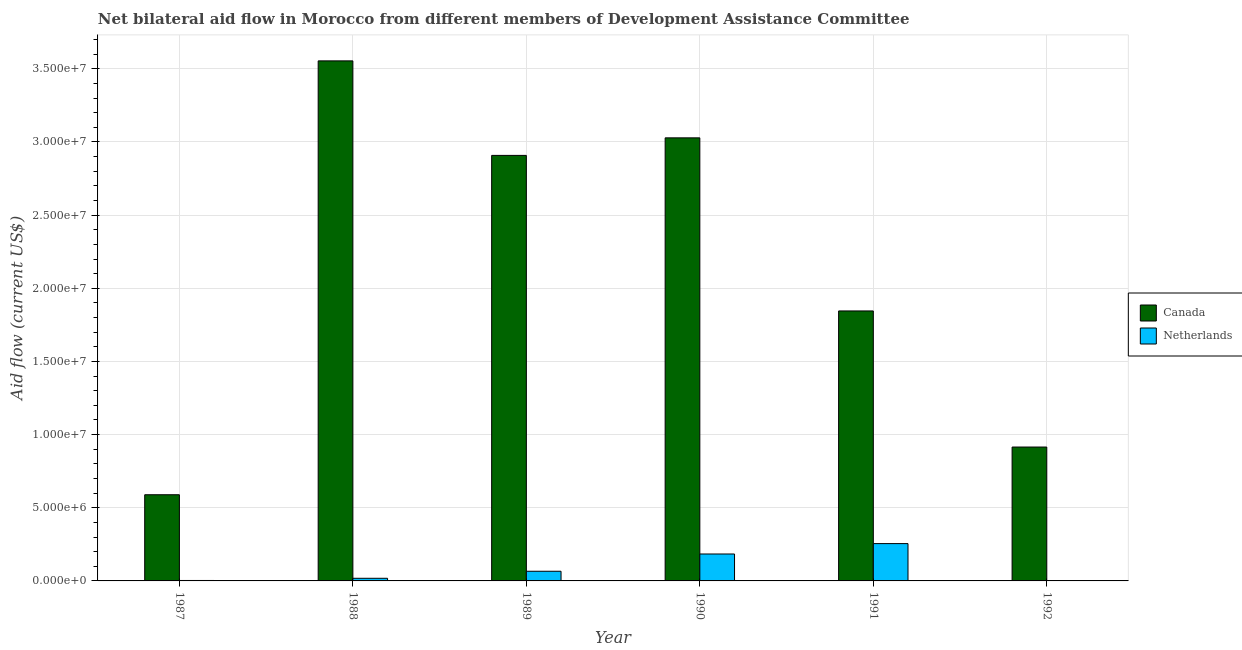How many different coloured bars are there?
Give a very brief answer. 2. Are the number of bars per tick equal to the number of legend labels?
Your response must be concise. No. Are the number of bars on each tick of the X-axis equal?
Offer a terse response. No. How many bars are there on the 1st tick from the left?
Offer a very short reply. 2. How many bars are there on the 2nd tick from the right?
Make the answer very short. 2. What is the amount of aid given by canada in 1991?
Make the answer very short. 1.84e+07. Across all years, what is the maximum amount of aid given by canada?
Provide a short and direct response. 3.55e+07. Across all years, what is the minimum amount of aid given by canada?
Ensure brevity in your answer.  5.89e+06. What is the total amount of aid given by netherlands in the graph?
Your response must be concise. 5.26e+06. What is the difference between the amount of aid given by netherlands in 1988 and that in 1991?
Make the answer very short. -2.37e+06. What is the difference between the amount of aid given by netherlands in 1990 and the amount of aid given by canada in 1992?
Give a very brief answer. 1.84e+06. What is the average amount of aid given by netherlands per year?
Ensure brevity in your answer.  8.77e+05. In the year 1991, what is the difference between the amount of aid given by netherlands and amount of aid given by canada?
Your response must be concise. 0. In how many years, is the amount of aid given by netherlands greater than 32000000 US$?
Offer a very short reply. 0. What is the ratio of the amount of aid given by canada in 1987 to that in 1990?
Your answer should be compact. 0.19. Is the amount of aid given by netherlands in 1987 less than that in 1988?
Offer a very short reply. Yes. Is the difference between the amount of aid given by canada in 1989 and 1991 greater than the difference between the amount of aid given by netherlands in 1989 and 1991?
Provide a succinct answer. No. What is the difference between the highest and the second highest amount of aid given by netherlands?
Your answer should be compact. 7.10e+05. What is the difference between the highest and the lowest amount of aid given by netherlands?
Provide a short and direct response. 2.55e+06. Is the sum of the amount of aid given by canada in 1988 and 1991 greater than the maximum amount of aid given by netherlands across all years?
Provide a short and direct response. Yes. How many bars are there?
Give a very brief answer. 11. How many years are there in the graph?
Provide a succinct answer. 6. What is the difference between two consecutive major ticks on the Y-axis?
Offer a terse response. 5.00e+06. Does the graph contain grids?
Offer a very short reply. Yes. How many legend labels are there?
Give a very brief answer. 2. How are the legend labels stacked?
Provide a succinct answer. Vertical. What is the title of the graph?
Provide a short and direct response. Net bilateral aid flow in Morocco from different members of Development Assistance Committee. What is the label or title of the X-axis?
Provide a short and direct response. Year. What is the label or title of the Y-axis?
Keep it short and to the point. Aid flow (current US$). What is the Aid flow (current US$) of Canada in 1987?
Give a very brief answer. 5.89e+06. What is the Aid flow (current US$) in Netherlands in 1987?
Keep it short and to the point. 3.00e+04. What is the Aid flow (current US$) in Canada in 1988?
Make the answer very short. 3.55e+07. What is the Aid flow (current US$) of Netherlands in 1988?
Keep it short and to the point. 1.80e+05. What is the Aid flow (current US$) of Canada in 1989?
Your answer should be compact. 2.91e+07. What is the Aid flow (current US$) in Netherlands in 1989?
Provide a short and direct response. 6.60e+05. What is the Aid flow (current US$) of Canada in 1990?
Offer a very short reply. 3.03e+07. What is the Aid flow (current US$) in Netherlands in 1990?
Keep it short and to the point. 1.84e+06. What is the Aid flow (current US$) in Canada in 1991?
Your answer should be compact. 1.84e+07. What is the Aid flow (current US$) of Netherlands in 1991?
Provide a short and direct response. 2.55e+06. What is the Aid flow (current US$) in Canada in 1992?
Offer a very short reply. 9.15e+06. Across all years, what is the maximum Aid flow (current US$) in Canada?
Give a very brief answer. 3.55e+07. Across all years, what is the maximum Aid flow (current US$) of Netherlands?
Your answer should be compact. 2.55e+06. Across all years, what is the minimum Aid flow (current US$) in Canada?
Make the answer very short. 5.89e+06. Across all years, what is the minimum Aid flow (current US$) of Netherlands?
Ensure brevity in your answer.  0. What is the total Aid flow (current US$) in Canada in the graph?
Make the answer very short. 1.28e+08. What is the total Aid flow (current US$) of Netherlands in the graph?
Your answer should be very brief. 5.26e+06. What is the difference between the Aid flow (current US$) in Canada in 1987 and that in 1988?
Offer a very short reply. -2.96e+07. What is the difference between the Aid flow (current US$) in Canada in 1987 and that in 1989?
Make the answer very short. -2.32e+07. What is the difference between the Aid flow (current US$) of Netherlands in 1987 and that in 1989?
Your answer should be compact. -6.30e+05. What is the difference between the Aid flow (current US$) of Canada in 1987 and that in 1990?
Keep it short and to the point. -2.44e+07. What is the difference between the Aid flow (current US$) in Netherlands in 1987 and that in 1990?
Your answer should be compact. -1.81e+06. What is the difference between the Aid flow (current US$) of Canada in 1987 and that in 1991?
Your answer should be very brief. -1.26e+07. What is the difference between the Aid flow (current US$) in Netherlands in 1987 and that in 1991?
Keep it short and to the point. -2.52e+06. What is the difference between the Aid flow (current US$) of Canada in 1987 and that in 1992?
Offer a terse response. -3.26e+06. What is the difference between the Aid flow (current US$) in Canada in 1988 and that in 1989?
Offer a terse response. 6.46e+06. What is the difference between the Aid flow (current US$) in Netherlands in 1988 and that in 1989?
Offer a terse response. -4.80e+05. What is the difference between the Aid flow (current US$) of Canada in 1988 and that in 1990?
Make the answer very short. 5.26e+06. What is the difference between the Aid flow (current US$) of Netherlands in 1988 and that in 1990?
Offer a terse response. -1.66e+06. What is the difference between the Aid flow (current US$) of Canada in 1988 and that in 1991?
Provide a short and direct response. 1.71e+07. What is the difference between the Aid flow (current US$) of Netherlands in 1988 and that in 1991?
Offer a very short reply. -2.37e+06. What is the difference between the Aid flow (current US$) of Canada in 1988 and that in 1992?
Offer a very short reply. 2.64e+07. What is the difference between the Aid flow (current US$) of Canada in 1989 and that in 1990?
Give a very brief answer. -1.20e+06. What is the difference between the Aid flow (current US$) in Netherlands in 1989 and that in 1990?
Make the answer very short. -1.18e+06. What is the difference between the Aid flow (current US$) in Canada in 1989 and that in 1991?
Give a very brief answer. 1.06e+07. What is the difference between the Aid flow (current US$) of Netherlands in 1989 and that in 1991?
Offer a very short reply. -1.89e+06. What is the difference between the Aid flow (current US$) of Canada in 1989 and that in 1992?
Keep it short and to the point. 1.99e+07. What is the difference between the Aid flow (current US$) of Canada in 1990 and that in 1991?
Give a very brief answer. 1.18e+07. What is the difference between the Aid flow (current US$) in Netherlands in 1990 and that in 1991?
Provide a short and direct response. -7.10e+05. What is the difference between the Aid flow (current US$) of Canada in 1990 and that in 1992?
Ensure brevity in your answer.  2.11e+07. What is the difference between the Aid flow (current US$) in Canada in 1991 and that in 1992?
Offer a very short reply. 9.30e+06. What is the difference between the Aid flow (current US$) in Canada in 1987 and the Aid flow (current US$) in Netherlands in 1988?
Provide a short and direct response. 5.71e+06. What is the difference between the Aid flow (current US$) of Canada in 1987 and the Aid flow (current US$) of Netherlands in 1989?
Your answer should be compact. 5.23e+06. What is the difference between the Aid flow (current US$) of Canada in 1987 and the Aid flow (current US$) of Netherlands in 1990?
Keep it short and to the point. 4.05e+06. What is the difference between the Aid flow (current US$) of Canada in 1987 and the Aid flow (current US$) of Netherlands in 1991?
Provide a succinct answer. 3.34e+06. What is the difference between the Aid flow (current US$) in Canada in 1988 and the Aid flow (current US$) in Netherlands in 1989?
Ensure brevity in your answer.  3.49e+07. What is the difference between the Aid flow (current US$) in Canada in 1988 and the Aid flow (current US$) in Netherlands in 1990?
Your answer should be very brief. 3.37e+07. What is the difference between the Aid flow (current US$) of Canada in 1988 and the Aid flow (current US$) of Netherlands in 1991?
Make the answer very short. 3.30e+07. What is the difference between the Aid flow (current US$) in Canada in 1989 and the Aid flow (current US$) in Netherlands in 1990?
Make the answer very short. 2.72e+07. What is the difference between the Aid flow (current US$) in Canada in 1989 and the Aid flow (current US$) in Netherlands in 1991?
Give a very brief answer. 2.65e+07. What is the difference between the Aid flow (current US$) of Canada in 1990 and the Aid flow (current US$) of Netherlands in 1991?
Offer a very short reply. 2.77e+07. What is the average Aid flow (current US$) in Canada per year?
Your response must be concise. 2.14e+07. What is the average Aid flow (current US$) of Netherlands per year?
Provide a short and direct response. 8.77e+05. In the year 1987, what is the difference between the Aid flow (current US$) of Canada and Aid flow (current US$) of Netherlands?
Ensure brevity in your answer.  5.86e+06. In the year 1988, what is the difference between the Aid flow (current US$) in Canada and Aid flow (current US$) in Netherlands?
Offer a very short reply. 3.54e+07. In the year 1989, what is the difference between the Aid flow (current US$) of Canada and Aid flow (current US$) of Netherlands?
Keep it short and to the point. 2.84e+07. In the year 1990, what is the difference between the Aid flow (current US$) in Canada and Aid flow (current US$) in Netherlands?
Provide a short and direct response. 2.84e+07. In the year 1991, what is the difference between the Aid flow (current US$) in Canada and Aid flow (current US$) in Netherlands?
Offer a terse response. 1.59e+07. What is the ratio of the Aid flow (current US$) in Canada in 1987 to that in 1988?
Your answer should be very brief. 0.17. What is the ratio of the Aid flow (current US$) in Netherlands in 1987 to that in 1988?
Make the answer very short. 0.17. What is the ratio of the Aid flow (current US$) of Canada in 1987 to that in 1989?
Keep it short and to the point. 0.2. What is the ratio of the Aid flow (current US$) of Netherlands in 1987 to that in 1989?
Provide a succinct answer. 0.05. What is the ratio of the Aid flow (current US$) of Canada in 1987 to that in 1990?
Offer a terse response. 0.19. What is the ratio of the Aid flow (current US$) of Netherlands in 1987 to that in 1990?
Provide a short and direct response. 0.02. What is the ratio of the Aid flow (current US$) of Canada in 1987 to that in 1991?
Ensure brevity in your answer.  0.32. What is the ratio of the Aid flow (current US$) of Netherlands in 1987 to that in 1991?
Give a very brief answer. 0.01. What is the ratio of the Aid flow (current US$) in Canada in 1987 to that in 1992?
Your answer should be compact. 0.64. What is the ratio of the Aid flow (current US$) in Canada in 1988 to that in 1989?
Offer a terse response. 1.22. What is the ratio of the Aid flow (current US$) of Netherlands in 1988 to that in 1989?
Offer a terse response. 0.27. What is the ratio of the Aid flow (current US$) in Canada in 1988 to that in 1990?
Your answer should be very brief. 1.17. What is the ratio of the Aid flow (current US$) of Netherlands in 1988 to that in 1990?
Give a very brief answer. 0.1. What is the ratio of the Aid flow (current US$) in Canada in 1988 to that in 1991?
Provide a succinct answer. 1.93. What is the ratio of the Aid flow (current US$) of Netherlands in 1988 to that in 1991?
Make the answer very short. 0.07. What is the ratio of the Aid flow (current US$) in Canada in 1988 to that in 1992?
Make the answer very short. 3.88. What is the ratio of the Aid flow (current US$) in Canada in 1989 to that in 1990?
Offer a very short reply. 0.96. What is the ratio of the Aid flow (current US$) in Netherlands in 1989 to that in 1990?
Offer a terse response. 0.36. What is the ratio of the Aid flow (current US$) in Canada in 1989 to that in 1991?
Your response must be concise. 1.58. What is the ratio of the Aid flow (current US$) of Netherlands in 1989 to that in 1991?
Keep it short and to the point. 0.26. What is the ratio of the Aid flow (current US$) in Canada in 1989 to that in 1992?
Keep it short and to the point. 3.18. What is the ratio of the Aid flow (current US$) in Canada in 1990 to that in 1991?
Offer a terse response. 1.64. What is the ratio of the Aid flow (current US$) of Netherlands in 1990 to that in 1991?
Provide a succinct answer. 0.72. What is the ratio of the Aid flow (current US$) in Canada in 1990 to that in 1992?
Give a very brief answer. 3.31. What is the ratio of the Aid flow (current US$) in Canada in 1991 to that in 1992?
Give a very brief answer. 2.02. What is the difference between the highest and the second highest Aid flow (current US$) of Canada?
Your answer should be compact. 5.26e+06. What is the difference between the highest and the second highest Aid flow (current US$) of Netherlands?
Make the answer very short. 7.10e+05. What is the difference between the highest and the lowest Aid flow (current US$) in Canada?
Make the answer very short. 2.96e+07. What is the difference between the highest and the lowest Aid flow (current US$) in Netherlands?
Keep it short and to the point. 2.55e+06. 